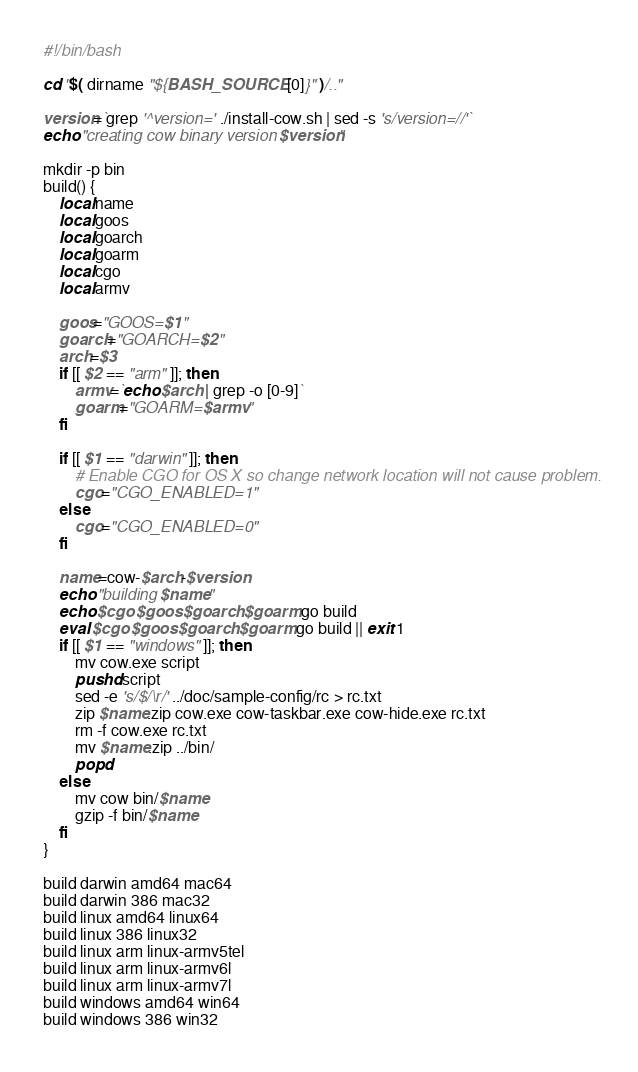<code> <loc_0><loc_0><loc_500><loc_500><_Bash_>#!/bin/bash

cd "$( dirname "${BASH_SOURCE[0]}" )/.."

version=`grep '^version=' ./install-cow.sh | sed -s 's/version=//'`
echo "creating cow binary version $version"

mkdir -p bin
build() {
    local name
    local goos
    local goarch
    local goarm
    local cgo
    local armv

    goos="GOOS=$1"
    goarch="GOARCH=$2"
    arch=$3
    if [[ $2 == "arm" ]]; then
        armv=`echo $arch | grep -o [0-9]`
        goarm="GOARM=$armv"
    fi

    if [[ $1 == "darwin" ]]; then
        # Enable CGO for OS X so change network location will not cause problem.
        cgo="CGO_ENABLED=1"
    else
        cgo="CGO_ENABLED=0"
    fi

    name=cow-$arch-$version
    echo "building $name"
    echo $cgo $goos $goarch $goarm go build
    eval $cgo $goos $goarch $goarm go build || exit 1
    if [[ $1 == "windows" ]]; then
        mv cow.exe script
        pushd script
        sed -e 's/$/\r/' ../doc/sample-config/rc > rc.txt
        zip $name.zip cow.exe cow-taskbar.exe cow-hide.exe rc.txt
        rm -f cow.exe rc.txt
        mv $name.zip ../bin/
        popd
    else
        mv cow bin/$name
        gzip -f bin/$name
    fi
}

build darwin amd64 mac64
build darwin 386 mac32
build linux amd64 linux64
build linux 386 linux32
build linux arm linux-armv5tel
build linux arm linux-armv6l
build linux arm linux-armv7l
build windows amd64 win64
build windows 386 win32
</code> 